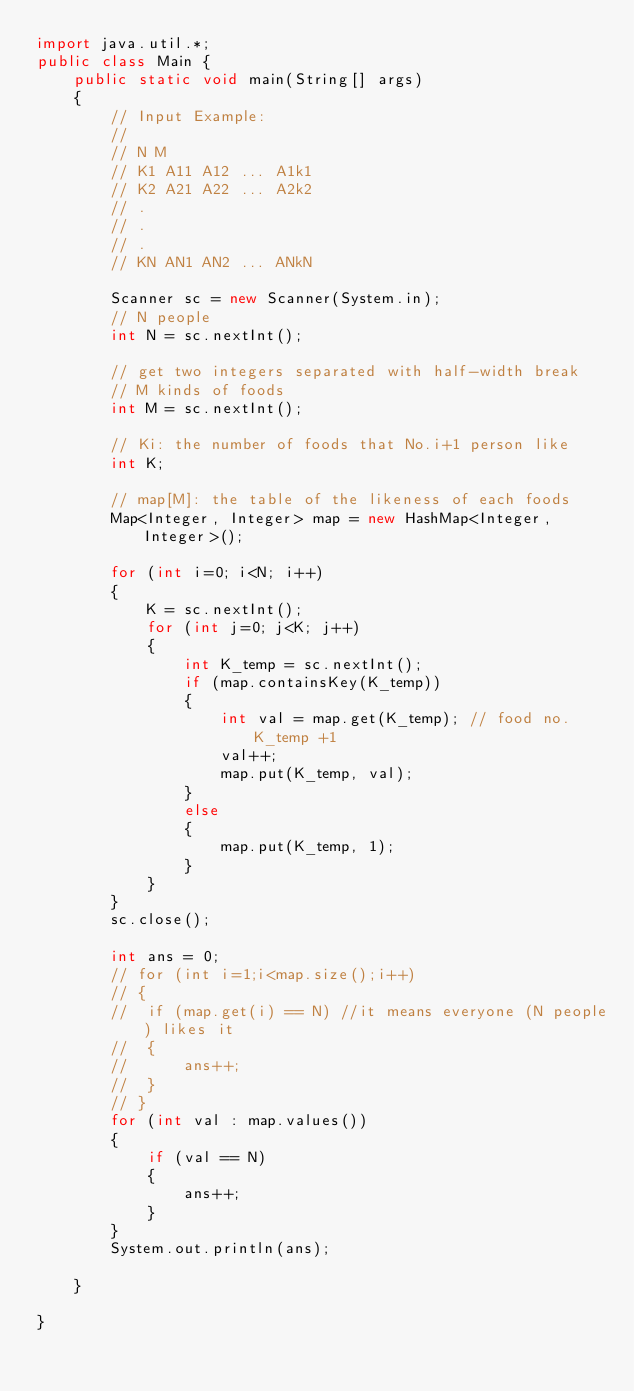<code> <loc_0><loc_0><loc_500><loc_500><_Java_>import java.util.*;
public class Main {
	public static void main(String[] args)
	{
		// Input Example:
		//
		// N M
		// K1 A11 A12 ... A1k1
		// K2 A21 A22 ... A2k2
		// .
		// .
		// .
		// KN AN1 AN2 ... ANkN

		Scanner sc = new Scanner(System.in);
		// N people
		int N = sc.nextInt();
		
		// get two integers separated with half-width break
		// M kinds of foods
		int M = sc.nextInt(); 

		// Ki: the number of foods that No.i+1 person like
		int K;

		// map[M]: the table of the likeness of each foods 
		Map<Integer, Integer> map = new HashMap<Integer, Integer>();

		for (int i=0; i<N; i++)
		{
			K = sc.nextInt();
			for (int j=0; j<K; j++)
			{
				int K_temp = sc.nextInt();
				if (map.containsKey(K_temp))
				{
					int val = map.get(K_temp); // food no. K_temp +1
					val++;
					map.put(K_temp, val);
				}
				else
				{
					map.put(K_temp, 1);
				}
			}
		}
		sc.close();

		int ans = 0;
		// for (int i=1;i<map.size();i++)
		// {
		// 	if (map.get(i) == N) //it means everyone (N people) likes it
		// 	{
		// 		ans++;
		// 	}
		// }
		for (int val : map.values())
		{
			if (val == N)
			{
				ans++;
			}
		}
		System.out.println(ans);
		
	}

}</code> 